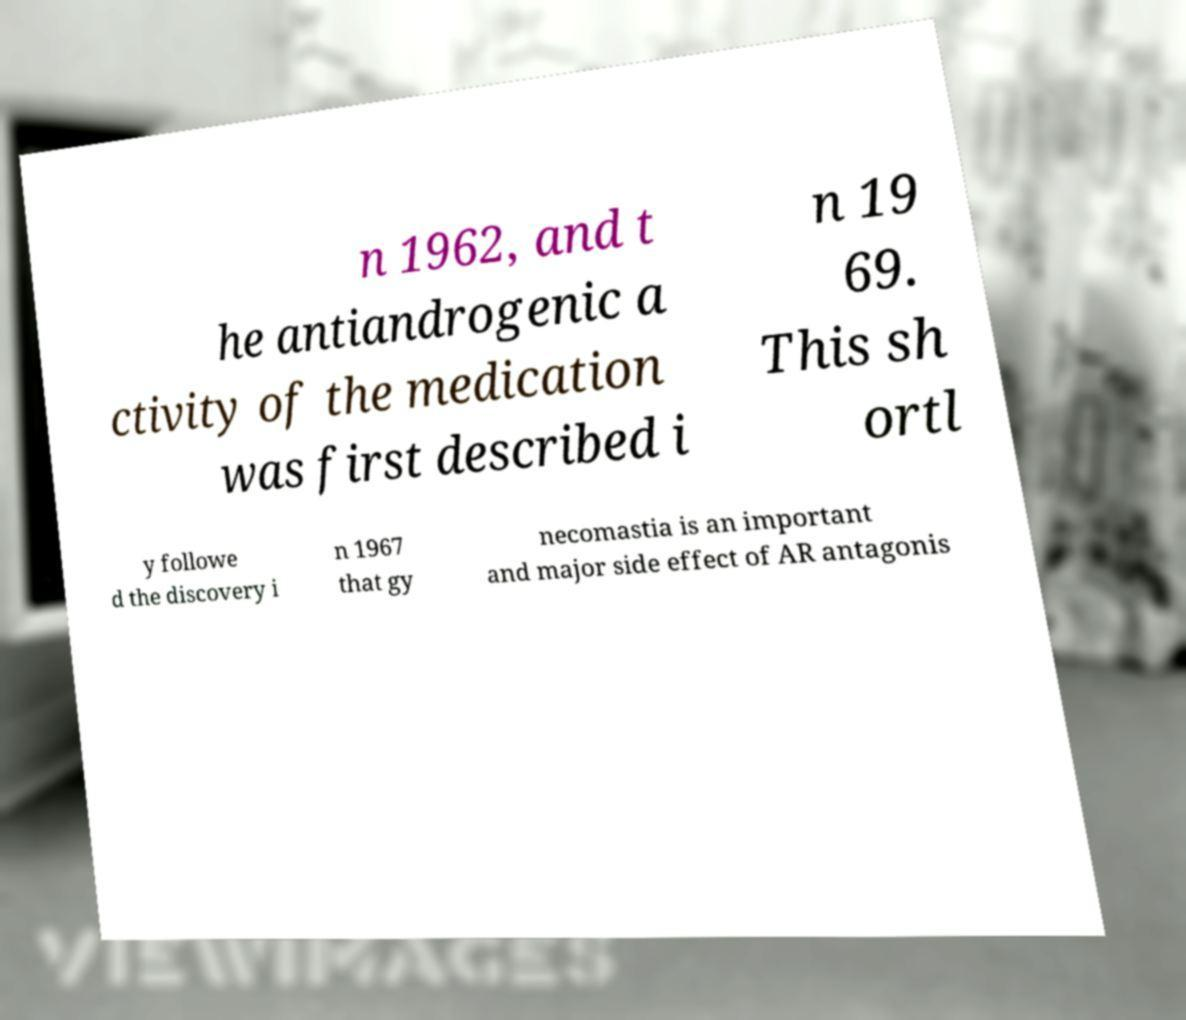Can you read and provide the text displayed in the image?This photo seems to have some interesting text. Can you extract and type it out for me? n 1962, and t he antiandrogenic a ctivity of the medication was first described i n 19 69. This sh ortl y followe d the discovery i n 1967 that gy necomastia is an important and major side effect of AR antagonis 